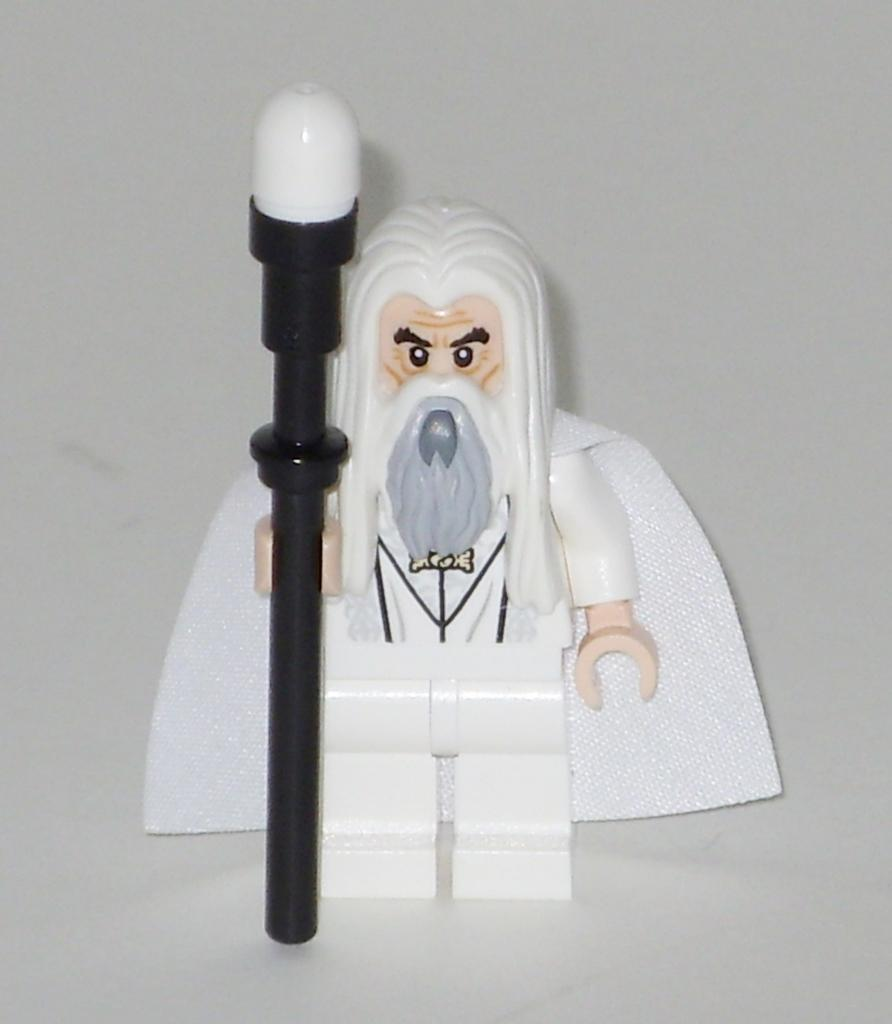What is the main subject of the picture? The main subject of the picture is a figurine. What is the figurine holding in its hand? The figurine is holding a pole in its hand. What color is the backdrop of the image? The backdrop of the image is a white surface. How many fish can be seen swimming in the bushes in the image? There are no fish or bushes present in the image; it features a figurine holding a pole against a white backdrop. 